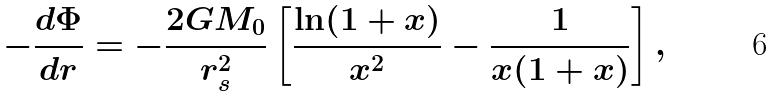Convert formula to latex. <formula><loc_0><loc_0><loc_500><loc_500>- \frac { d \Phi } { d r } = - \frac { 2 G M _ { 0 } } { r _ { s } ^ { 2 } } \left [ \frac { \ln ( 1 + x ) } { x ^ { 2 } } - \frac { 1 } { x ( 1 + x ) } \right ] ,</formula> 